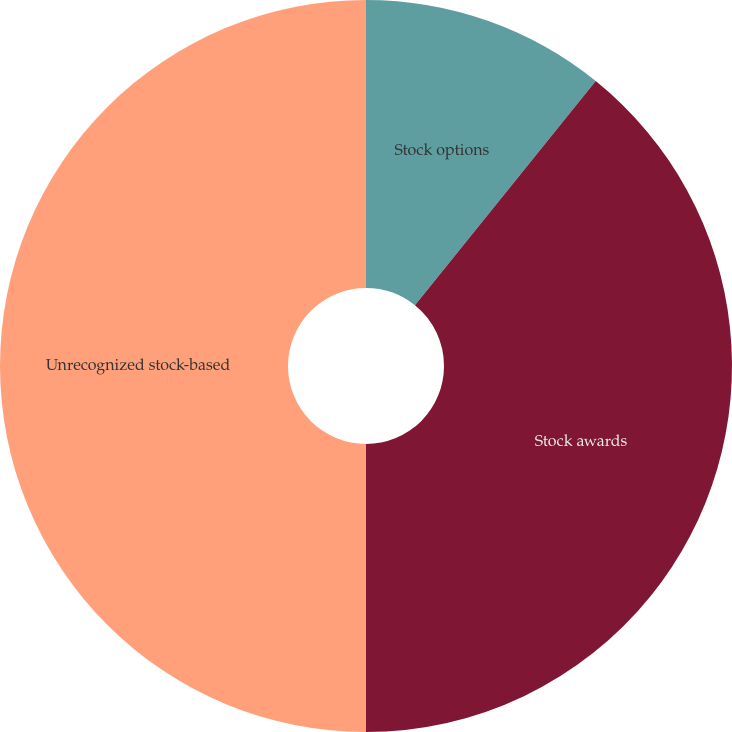<chart> <loc_0><loc_0><loc_500><loc_500><pie_chart><fcel>Stock options<fcel>Stock awards<fcel>Unrecognized stock-based<nl><fcel>10.8%<fcel>39.2%<fcel>50.0%<nl></chart> 